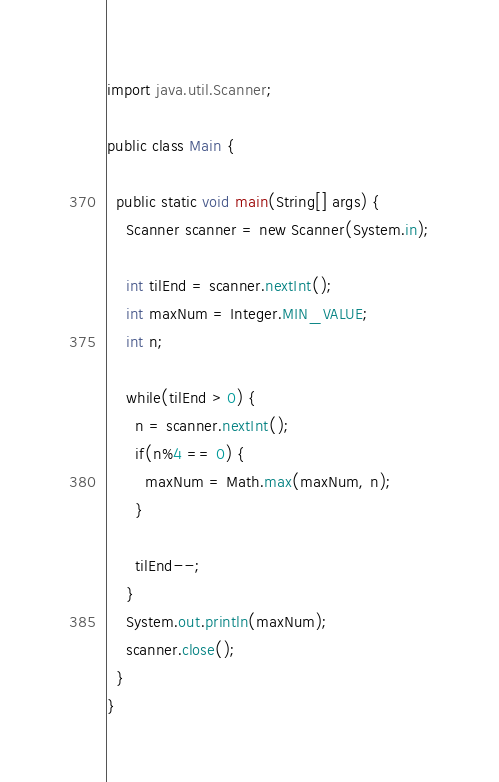Convert code to text. <code><loc_0><loc_0><loc_500><loc_500><_Java_>import java.util.Scanner;

public class Main {

  public static void main(String[] args) {
    Scanner scanner = new Scanner(System.in);

    int tilEnd = scanner.nextInt();
    int maxNum = Integer.MIN_VALUE;
    int n;

    while(tilEnd > 0) {
      n = scanner.nextInt();
      if(n%4 == 0) {
        maxNum = Math.max(maxNum, n);
      }

      tilEnd--;
    }
    System.out.println(maxNum);
    scanner.close();
  }
}</code> 